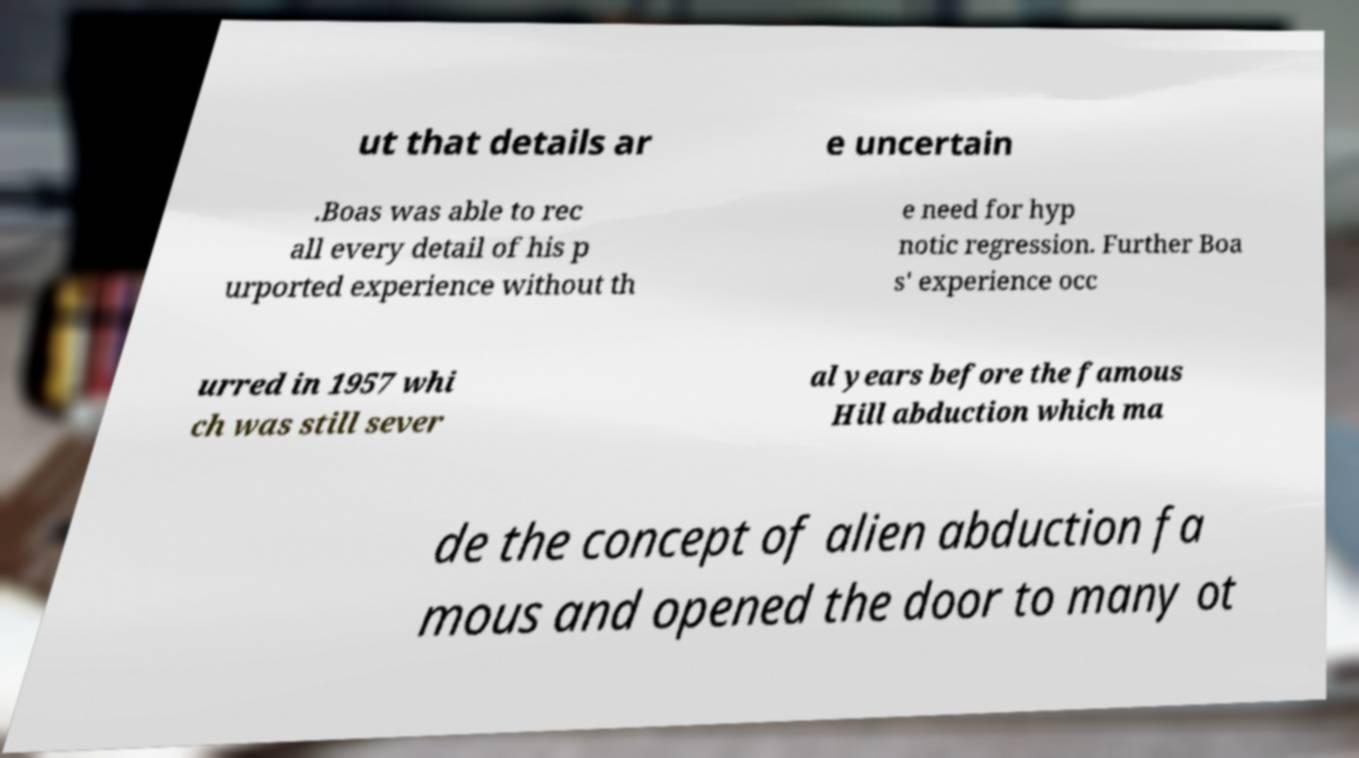Please read and relay the text visible in this image. What does it say? ut that details ar e uncertain .Boas was able to rec all every detail of his p urported experience without th e need for hyp notic regression. Further Boa s' experience occ urred in 1957 whi ch was still sever al years before the famous Hill abduction which ma de the concept of alien abduction fa mous and opened the door to many ot 